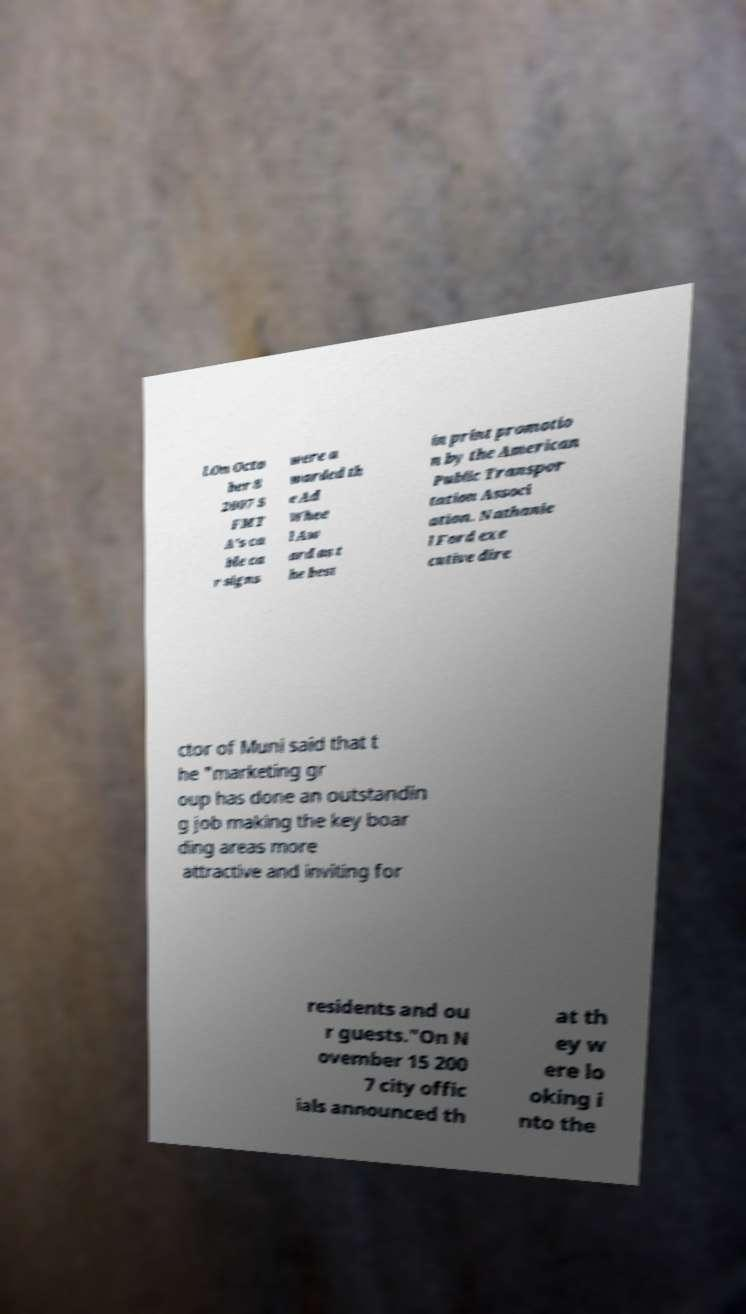Could you assist in decoding the text presented in this image and type it out clearly? l.On Octo ber 8 2007 S FMT A's ca ble ca r signs were a warded th e Ad Whee l Aw ard as t he best in print promotio n by the American Public Transpor tation Associ ation. Nathanie l Ford exe cutive dire ctor of Muni said that t he "marketing gr oup has done an outstandin g job making the key boar ding areas more attractive and inviting for residents and ou r guests."On N ovember 15 200 7 city offic ials announced th at th ey w ere lo oking i nto the 